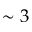Convert formula to latex. <formula><loc_0><loc_0><loc_500><loc_500>\sim 3</formula> 